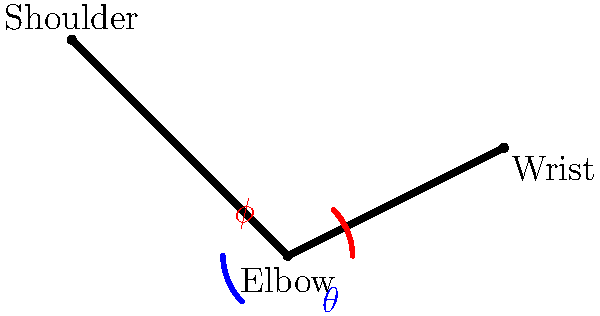In a standard bicep curl exercise, which angle ($\theta$ or $\phi$) represents the elbow flexion angle, and how does this angle typically change during the concentric phase of the movement? To answer this question, let's break it down step-by-step:

1. In the skeletal model, we see two angles marked:
   - $\theta$ (blue) is the angle between the upper arm and forearm
   - $\phi$ (red) is the supplementary angle to $\theta$

2. The elbow flexion angle is the angle between the upper arm and forearm. This is represented by $\theta$ (blue) in the diagram.

3. During a bicep curl:
   - The concentric phase is when the weight is being lifted towards the shoulder
   - This action involves flexing the elbow joint

4. As the elbow flexes during the concentric phase:
   - The angle $\theta$ decreases
   - It starts at close to 180° when the arm is fully extended
   - It ends at about 30-45° at the top of the curl, depending on individual flexibility

5. Conversely, the angle $\phi$ increases during this movement, but it's not the primary angle we use to describe elbow flexion.

Therefore, $\theta$ represents the elbow flexion angle, and it decreases during the concentric phase of a bicep curl.
Answer: $\theta$; decreases 